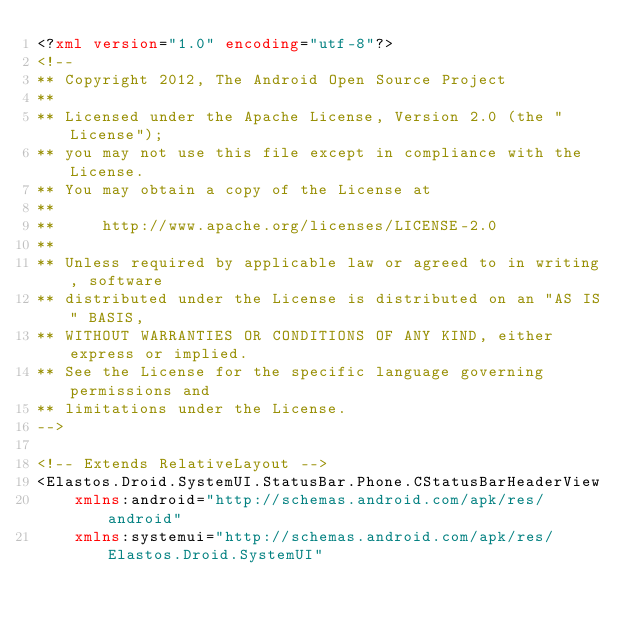Convert code to text. <code><loc_0><loc_0><loc_500><loc_500><_XML_><?xml version="1.0" encoding="utf-8"?>
<!--
** Copyright 2012, The Android Open Source Project
**
** Licensed under the Apache License, Version 2.0 (the "License");
** you may not use this file except in compliance with the License.
** You may obtain a copy of the License at
**
**     http://www.apache.org/licenses/LICENSE-2.0
**
** Unless required by applicable law or agreed to in writing, software
** distributed under the License is distributed on an "AS IS" BASIS,
** WITHOUT WARRANTIES OR CONDITIONS OF ANY KIND, either express or implied.
** See the License for the specific language governing permissions and
** limitations under the License.
-->

<!-- Extends RelativeLayout -->
<Elastos.Droid.SystemUI.StatusBar.Phone.CStatusBarHeaderView
    xmlns:android="http://schemas.android.com/apk/res/android"
    xmlns:systemui="http://schemas.android.com/apk/res/Elastos.Droid.SystemUI"</code> 